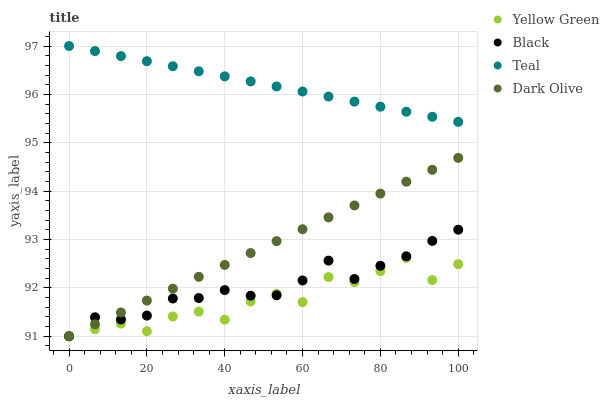Does Yellow Green have the minimum area under the curve?
Answer yes or no. Yes. Does Teal have the maximum area under the curve?
Answer yes or no. Yes. Does Black have the minimum area under the curve?
Answer yes or no. No. Does Black have the maximum area under the curve?
Answer yes or no. No. Is Teal the smoothest?
Answer yes or no. Yes. Is Yellow Green the roughest?
Answer yes or no. Yes. Is Black the smoothest?
Answer yes or no. No. Is Black the roughest?
Answer yes or no. No. Does Dark Olive have the lowest value?
Answer yes or no. Yes. Does Teal have the lowest value?
Answer yes or no. No. Does Teal have the highest value?
Answer yes or no. Yes. Does Black have the highest value?
Answer yes or no. No. Is Dark Olive less than Teal?
Answer yes or no. Yes. Is Teal greater than Dark Olive?
Answer yes or no. Yes. Does Black intersect Yellow Green?
Answer yes or no. Yes. Is Black less than Yellow Green?
Answer yes or no. No. Is Black greater than Yellow Green?
Answer yes or no. No. Does Dark Olive intersect Teal?
Answer yes or no. No. 